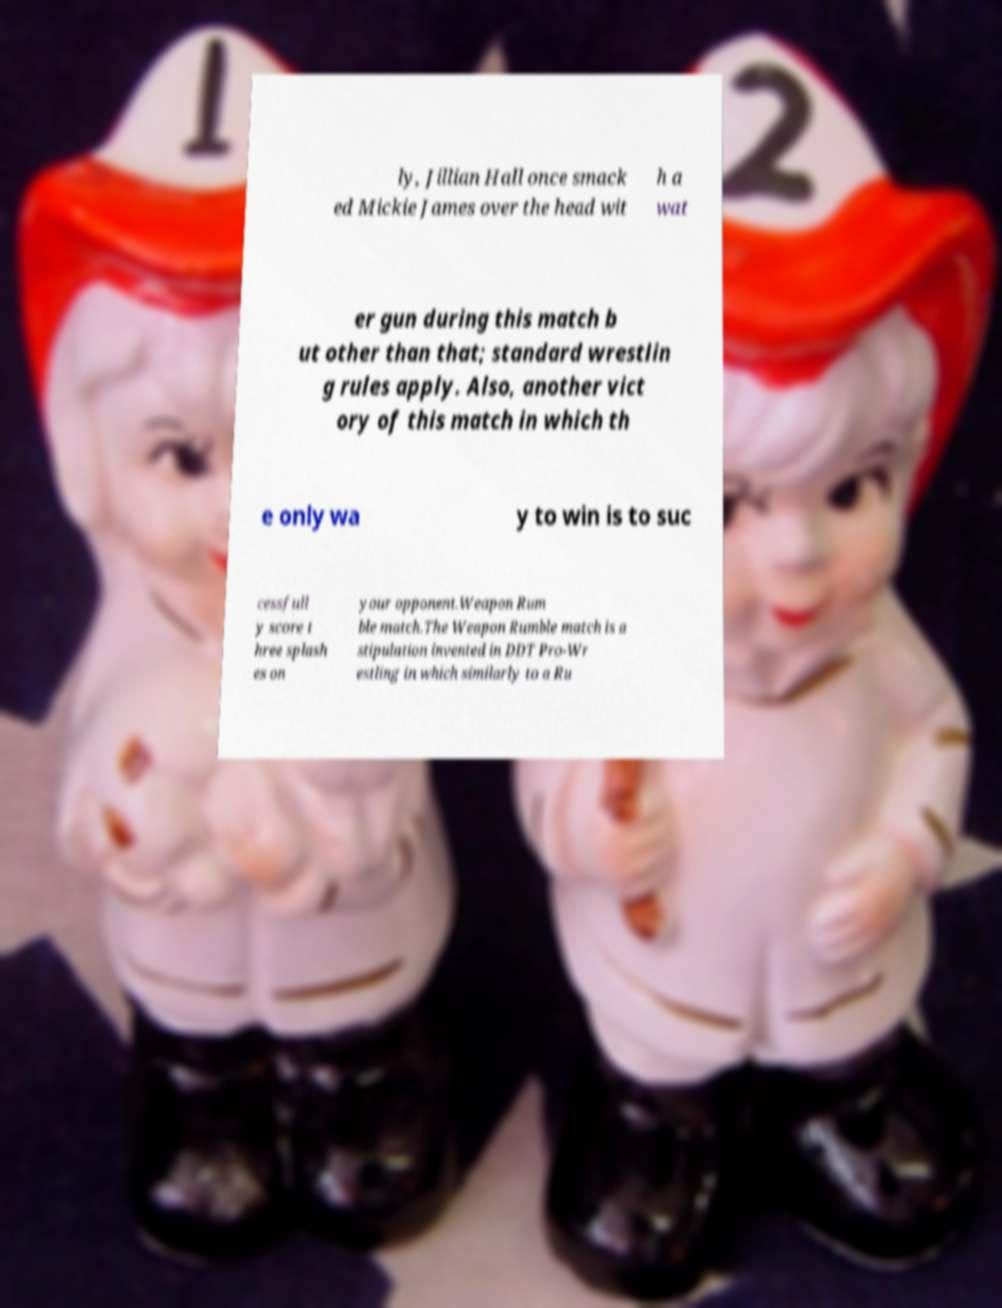Please read and relay the text visible in this image. What does it say? ly, Jillian Hall once smack ed Mickie James over the head wit h a wat er gun during this match b ut other than that; standard wrestlin g rules apply. Also, another vict ory of this match in which th e only wa y to win is to suc cessfull y score t hree splash es on your opponent.Weapon Rum ble match.The Weapon Rumble match is a stipulation invented in DDT Pro-Wr estling in which similarly to a Ru 